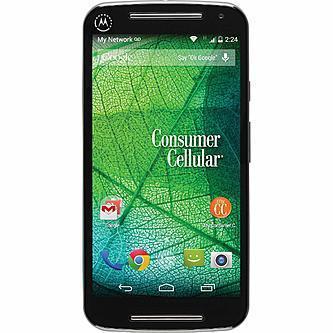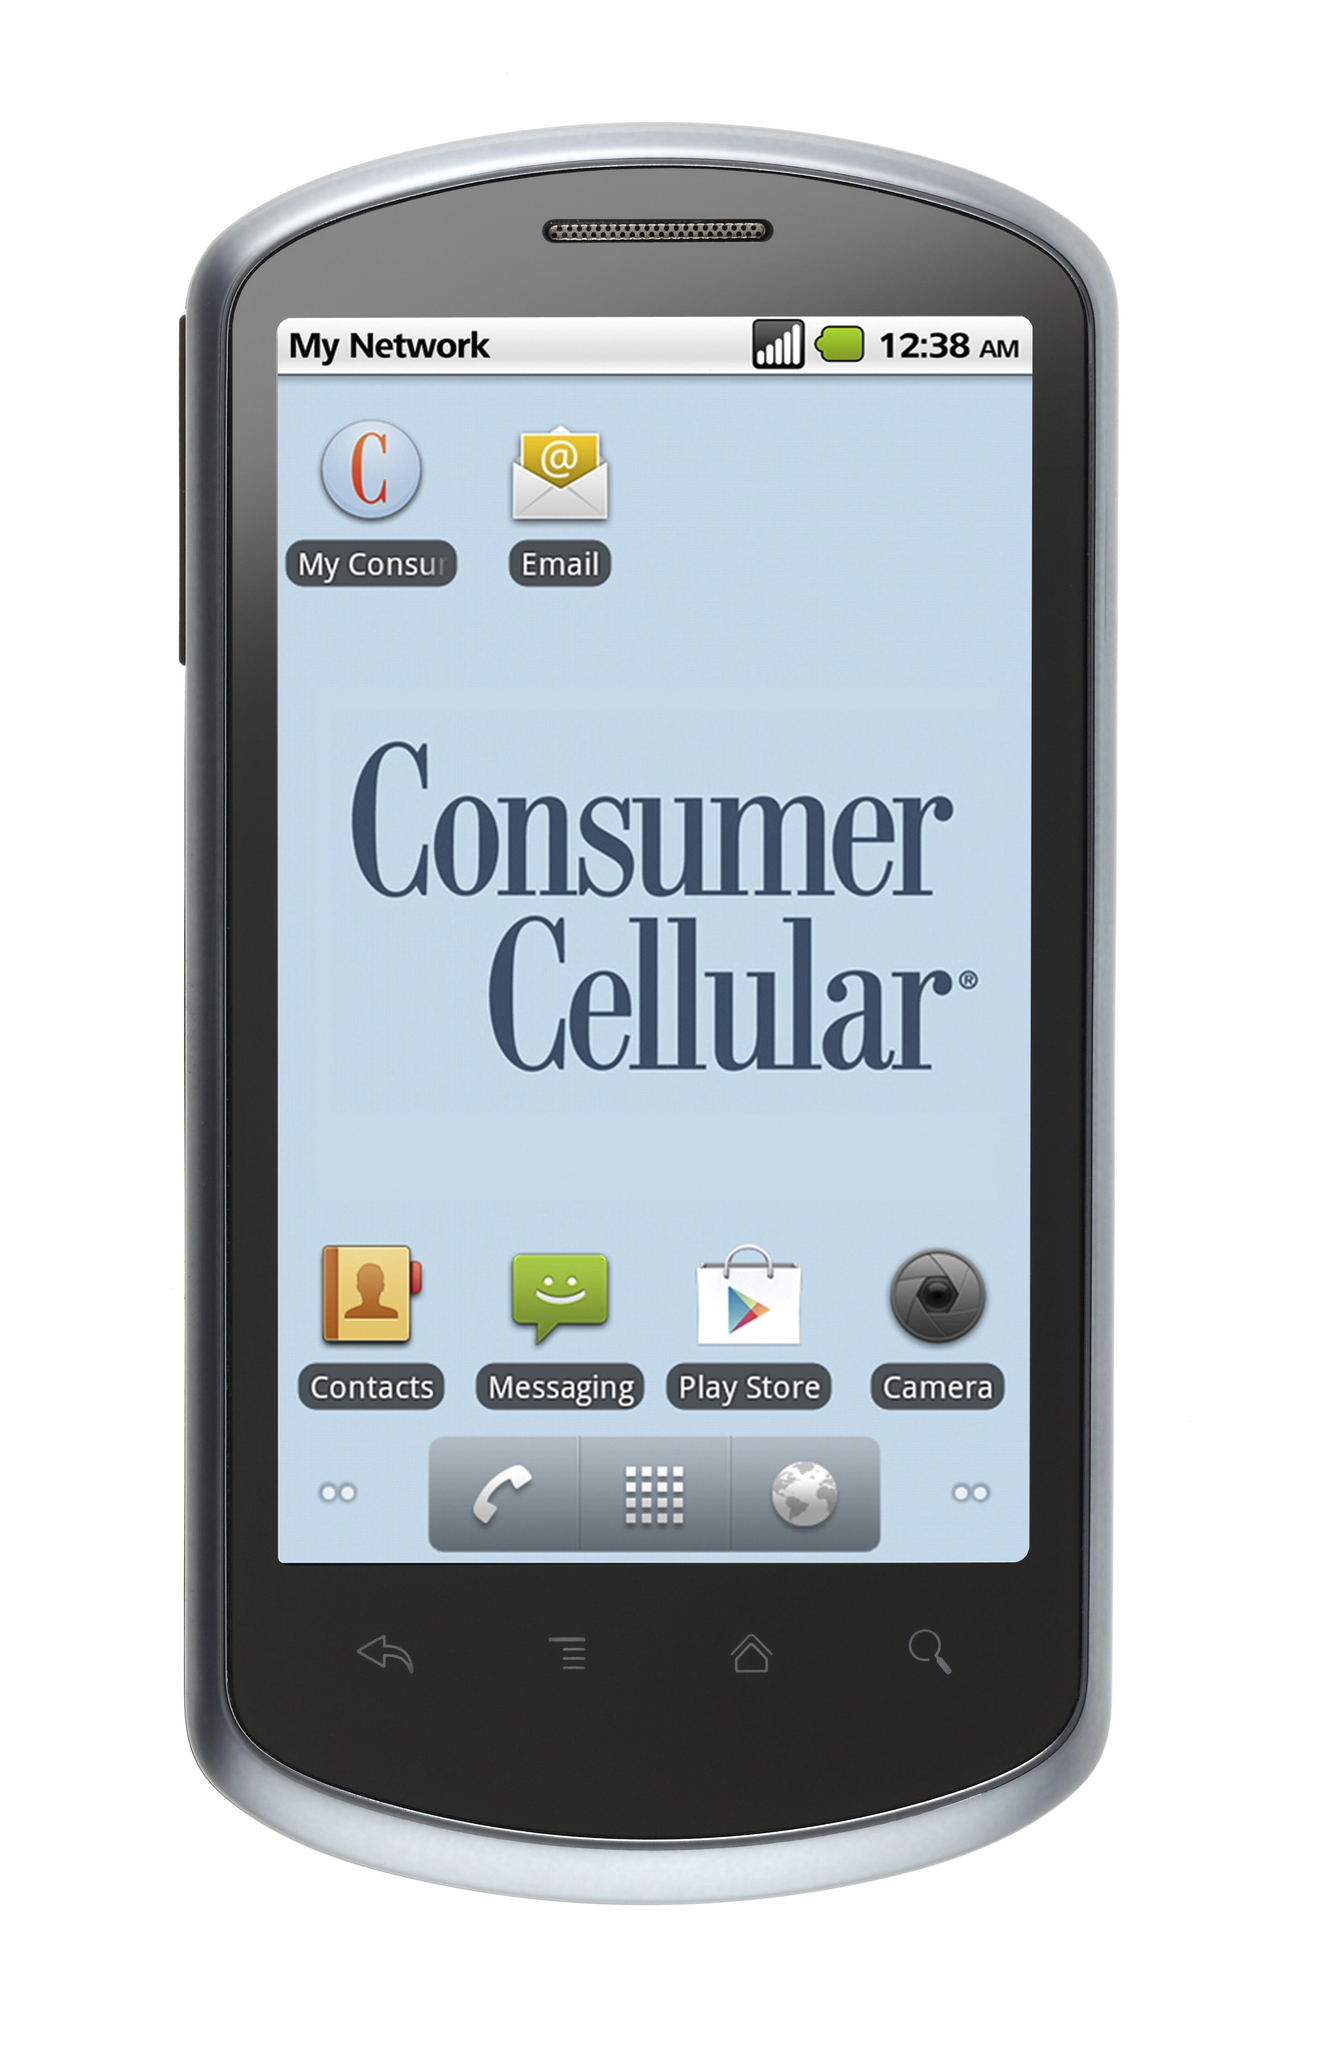The first image is the image on the left, the second image is the image on the right. Considering the images on both sides, is "Neither phone is an iPhone." valid? Answer yes or no. Yes. The first image is the image on the left, the second image is the image on the right. For the images shown, is this caption "Each image shows a rectangular device with flat ends and sides, rounded corners, and 'lit' screen displayed head-on, and at least one of the devices is black." true? Answer yes or no. No. 